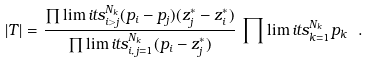<formula> <loc_0><loc_0><loc_500><loc_500>| T | = \frac { \prod \lim i t s _ { i > j } ^ { N _ { k } } ( p _ { i } - p _ { j } ) ( z _ { j } ^ { * } - z _ { i } ^ { * } ) } { \prod \lim i t s _ { i , \, j = 1 } ^ { N _ { k } } ( p _ { i } - z _ { j } ^ { * } ) } \, \prod \lim i t s _ { k = 1 } ^ { N _ { k } } p _ { k } \ .</formula> 